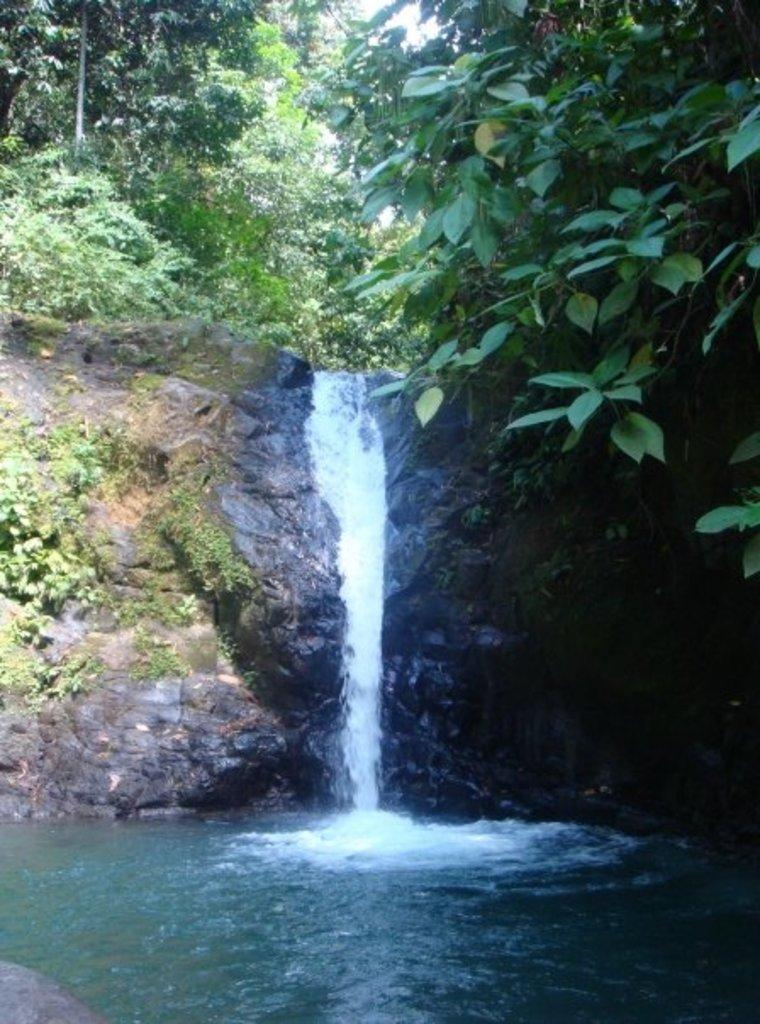What natural feature is the main subject of the image? There is a waterfall in the image. What can be seen near the waterfall? There are plants on the rocks near the waterfall. What type of vegetation is visible behind the rocks? There are trees behind the rocks. What is visible at the top of the image? The sky is visible at the top of the image. Can you see a rabbit hopping near the waterfall in the image? There is no rabbit present in the image. What rule is being enforced by the waterfall in the image? The waterfall is a natural feature and does not enforce any rules. 